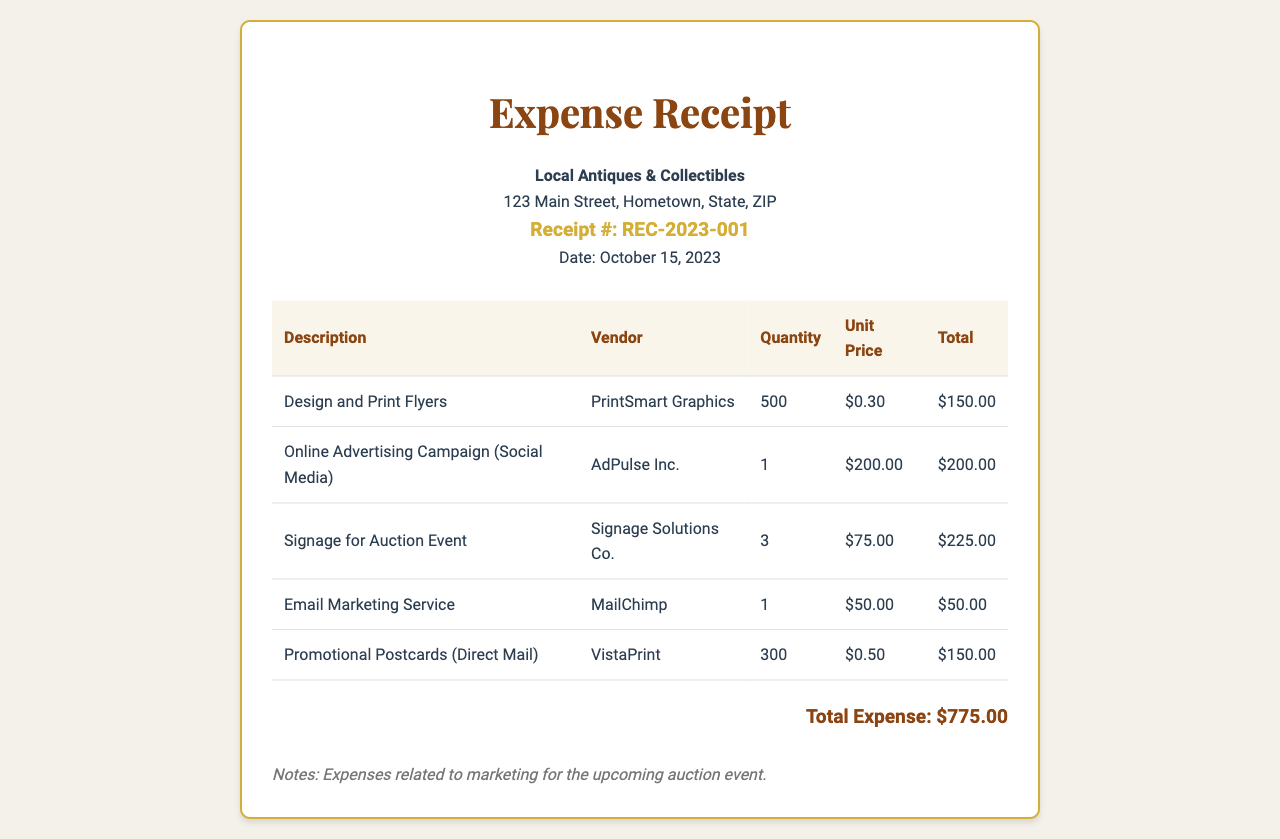What is the total expense? The total expense is found in the summary section of the document, which lists the overall cost related to the marketing efforts.
Answer: $775.00 What is the date on the receipt? The date can be found directly under the receipt number in the header section of the document.
Answer: October 15, 2023 Who is the vendor for the online advertising campaign? The vendor for this particular service is specified in the second row of the expenses table.
Answer: AdPulse Inc How many flyers were designed and printed? The quantity of flyers is listed in the first row of the expenses table under the quantity column.
Answer: 500 What was the unit price for signage? The unit price of signage can be found in the third row of the expenses table, which lists costs per item.
Answer: $75.00 Which company provided the email marketing service? The company offering the email marketing service is mentioned in the fourth row of the expenses table.
Answer: MailChimp How much did the promotional postcards cost in total? The total cost for promotional postcards can be calculated from the corresponding row in the table, where both quantity and unit price are listed.
Answer: $150.00 What is the receipt number? The receipt number is indicated in the header section of the document and provides a unique identifier for this expense receipt.
Answer: REC-2023-001 What are the notes regarding the expenses? The notes section at the bottom of the document provides context regarding the nature of the expenses.
Answer: Expenses related to marketing for the upcoming auction event 